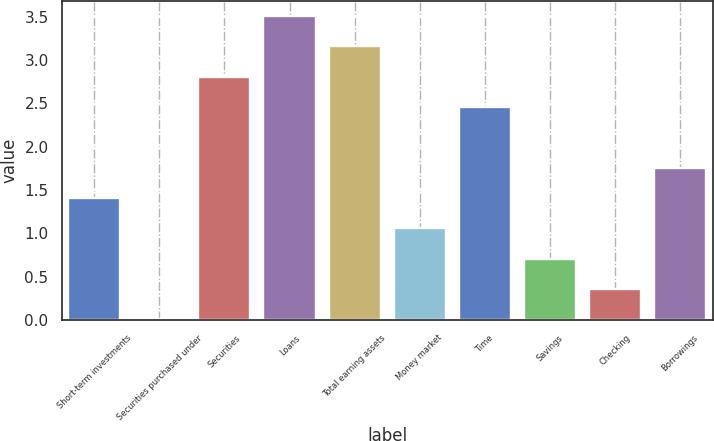Convert chart to OTSL. <chart><loc_0><loc_0><loc_500><loc_500><bar_chart><fcel>Short-term investments<fcel>Securities purchased under<fcel>Securities<fcel>Loans<fcel>Total earning assets<fcel>Money market<fcel>Time<fcel>Savings<fcel>Checking<fcel>Borrowings<nl><fcel>1.41<fcel>0.01<fcel>2.81<fcel>3.51<fcel>3.16<fcel>1.06<fcel>2.46<fcel>0.71<fcel>0.36<fcel>1.76<nl></chart> 